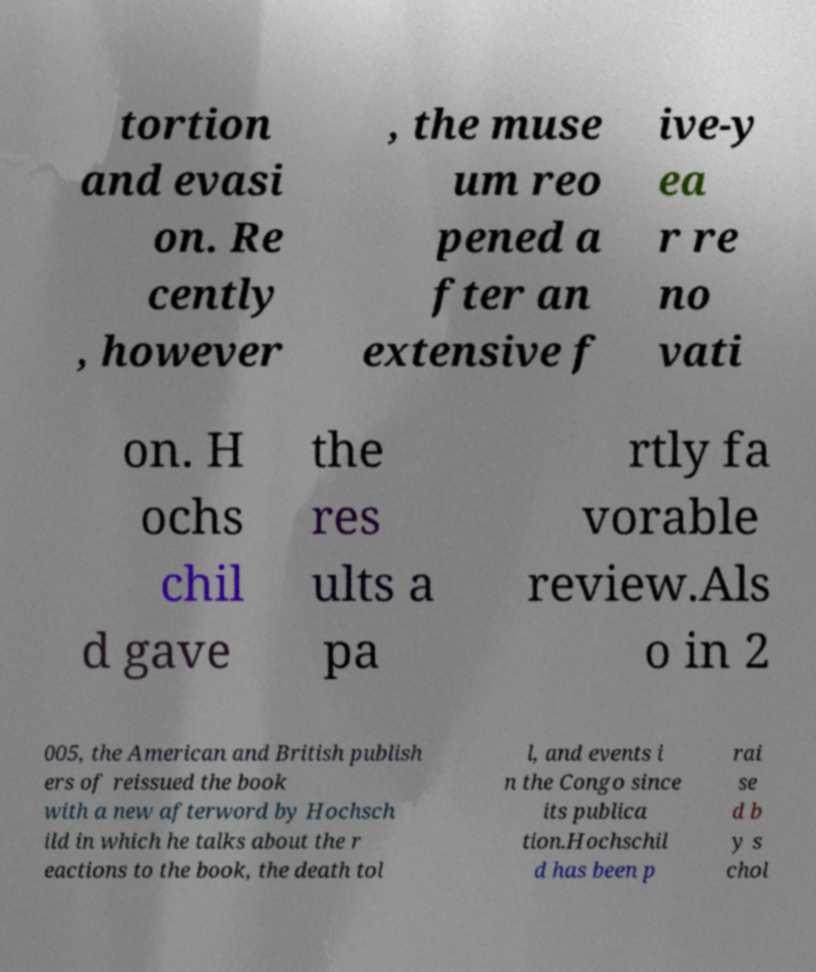There's text embedded in this image that I need extracted. Can you transcribe it verbatim? tortion and evasi on. Re cently , however , the muse um reo pened a fter an extensive f ive-y ea r re no vati on. H ochs chil d gave the res ults a pa rtly fa vorable review.Als o in 2 005, the American and British publish ers of reissued the book with a new afterword by Hochsch ild in which he talks about the r eactions to the book, the death tol l, and events i n the Congo since its publica tion.Hochschil d has been p rai se d b y s chol 